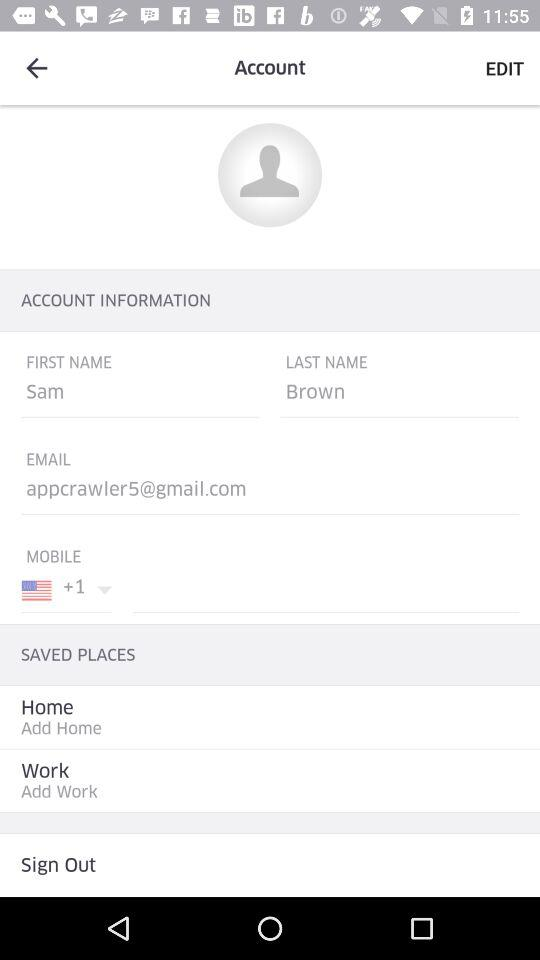What is the last name? The last name is Brown. 